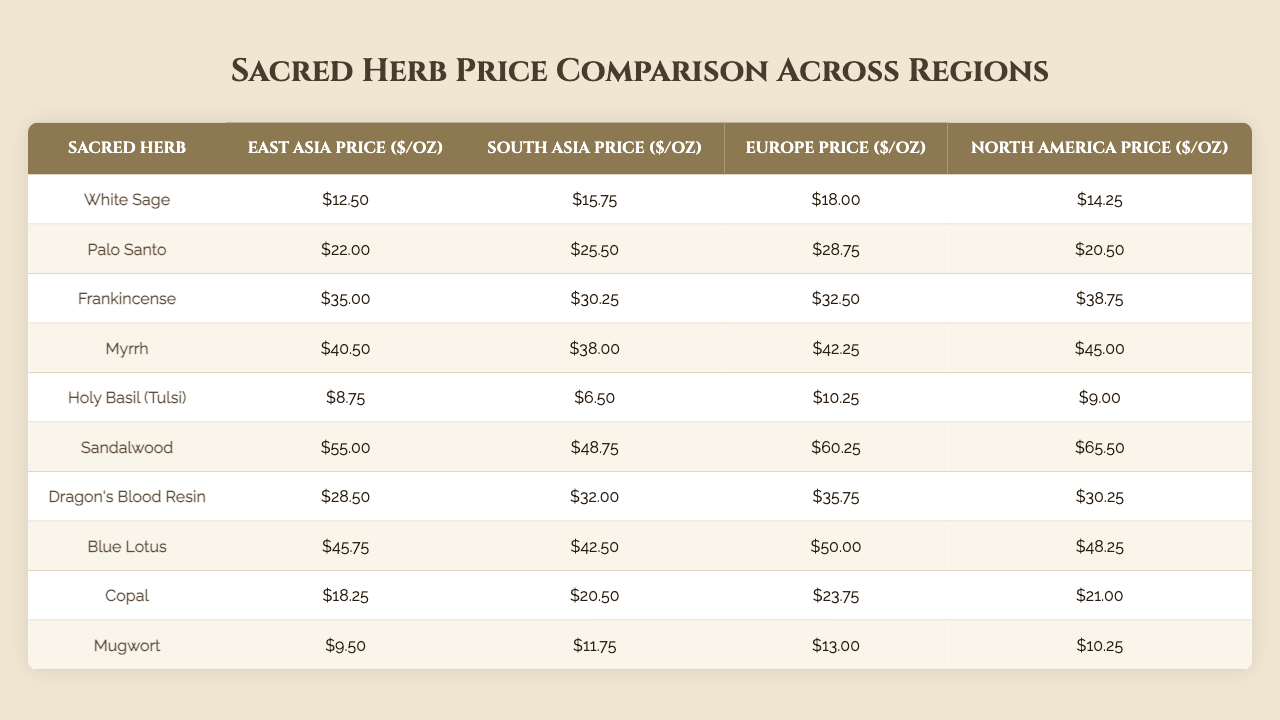What is the price of White Sage in South Asia? The table lists the price of White Sage in the South Asia column, which shows $15.75.
Answer: $15.75 Which herb is the most expensive in North America? The table shows the prices of all herbs in the North America column. Myrrh is listed as the highest price at $45.00.
Answer: Myrrh What is the price difference of Palo Santo between East Asia and Europe? To find the difference, subtract the price of Palo Santo in East Asia ($22.00) from the price in Europe ($28.75), resulting in $28.75 - $22.00 = $6.75.
Answer: $6.75 Is the price of Holy Basil (Tulsi) lower in South Asia compared to North America? The price of Holy Basil (Tulsi) in South Asia is $6.50, while in North America it is $9.00. Since $6.50 is less than $9.00, the statement is true.
Answer: Yes What is the average price of Sandalwood across all regions? The prices of Sandalwood in each region are: East Asia ($55.00), South Asia ($48.75), Europe ($60.25), North America ($65.50). The sum is $55.00 + $48.75 + $60.25 + $65.50 = $229.50. Dividing by 4 gives an average of $229.50 / 4 = $57.375.
Answer: $57.38 Which region has the highest price for Frankincense? The table shows Frankincense prices across different regions. North America is the highest at $38.75, compared to other regions.
Answer: North America What is the total price of Myrrh in Europe and North America combined? The price of Myrrh is $42.25 in Europe and $45.00 in North America. Adding these gives $42.25 + $45.00 = $87.25.
Answer: $87.25 Is the price of Dragon's Blood Resin higher in South Asia or North America? Dragon's Blood Resin is priced at $32.00 in South Asia and $30.25 in North America. Since $32.00 is greater than $30.25, the price is higher in South Asia.
Answer: South Asia What herb has a price greater than $40 in Europe? The herbs priced over $40 in Europe are Myrrh ($42.25) and Sandalwood ($60.25).
Answer: Myrrh, Sandalwood What is the lowest priced herb among all regions? Holy Basil (Tulsi) has the lowest price in South Asia at $6.50 compared to other herbs' prices across all regions.
Answer: Holy Basil (Tulsi) 